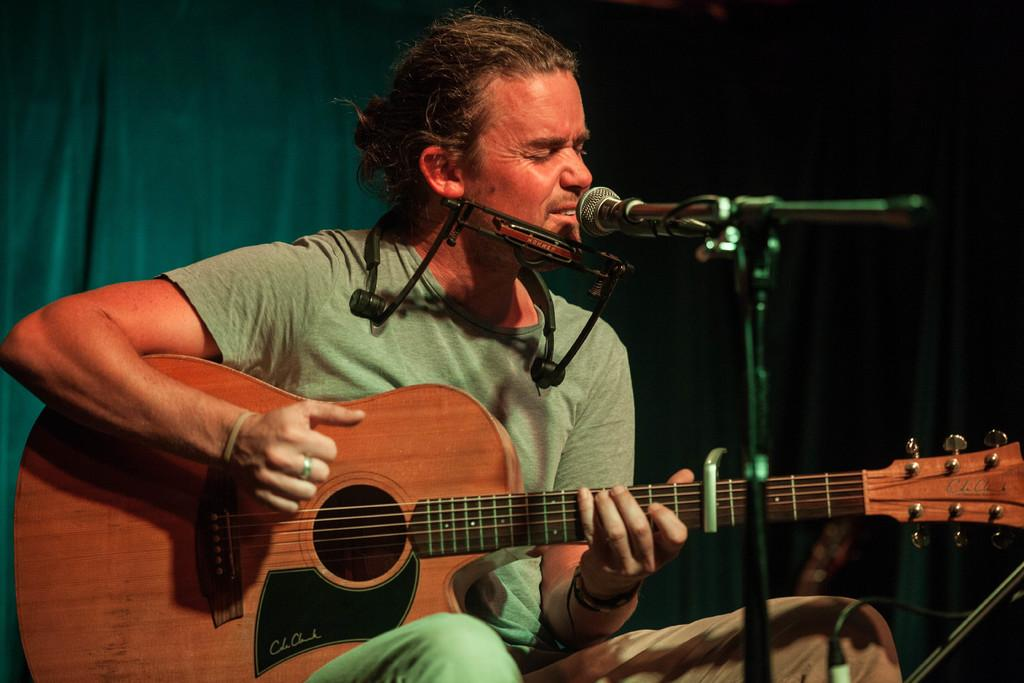How many people are in the image? There is one person in the image. What is the person doing in the image? The person is sitting on a chair and playing a guitar. What object is in front of the person? There is a microphone in front of the person. What can be seen behind the person? There is a big curtain behind the person. What type of songs is the group performing in the image? There is no group present in the image, and therefore no group performance can be observed. 